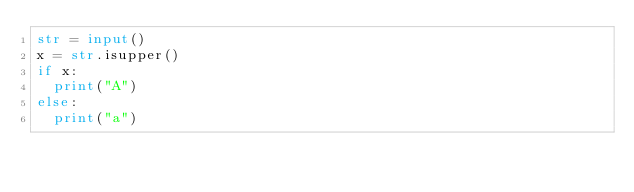Convert code to text. <code><loc_0><loc_0><loc_500><loc_500><_Python_>str = input()
x = str.isupper()
if x:
  print("A")
else:
  print("a")</code> 